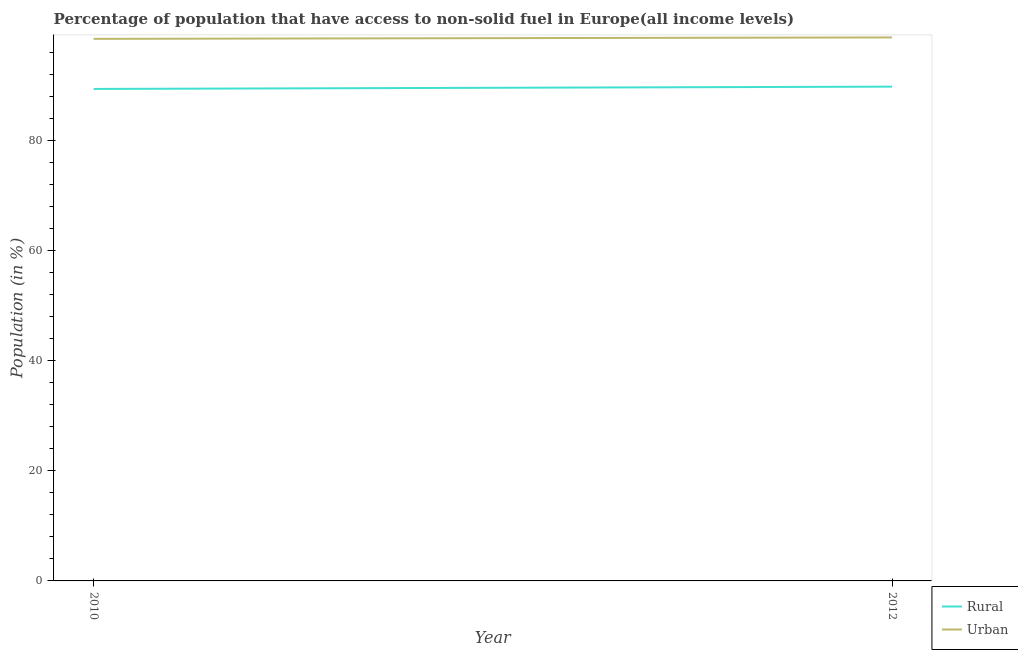Does the line corresponding to urban population intersect with the line corresponding to rural population?
Make the answer very short. No. Is the number of lines equal to the number of legend labels?
Your answer should be compact. Yes. What is the rural population in 2012?
Your answer should be very brief. 89.81. Across all years, what is the maximum urban population?
Your answer should be very brief. 98.74. Across all years, what is the minimum rural population?
Offer a very short reply. 89.39. In which year was the urban population maximum?
Offer a very short reply. 2012. In which year was the urban population minimum?
Provide a short and direct response. 2010. What is the total rural population in the graph?
Keep it short and to the point. 179.19. What is the difference between the rural population in 2010 and that in 2012?
Provide a succinct answer. -0.42. What is the difference between the rural population in 2012 and the urban population in 2010?
Make the answer very short. -8.68. What is the average urban population per year?
Give a very brief answer. 98.62. In the year 2010, what is the difference between the urban population and rural population?
Provide a succinct answer. 9.1. What is the ratio of the rural population in 2010 to that in 2012?
Make the answer very short. 1. Is the rural population in 2010 less than that in 2012?
Give a very brief answer. Yes. Is the rural population strictly greater than the urban population over the years?
Provide a short and direct response. No. Does the graph contain any zero values?
Keep it short and to the point. No. Where does the legend appear in the graph?
Provide a succinct answer. Bottom right. How many legend labels are there?
Give a very brief answer. 2. How are the legend labels stacked?
Your response must be concise. Vertical. What is the title of the graph?
Offer a terse response. Percentage of population that have access to non-solid fuel in Europe(all income levels). Does "Male" appear as one of the legend labels in the graph?
Offer a terse response. No. What is the label or title of the Y-axis?
Offer a very short reply. Population (in %). What is the Population (in %) of Rural in 2010?
Make the answer very short. 89.39. What is the Population (in %) of Urban in 2010?
Provide a succinct answer. 98.49. What is the Population (in %) in Rural in 2012?
Your response must be concise. 89.81. What is the Population (in %) of Urban in 2012?
Your answer should be compact. 98.74. Across all years, what is the maximum Population (in %) of Rural?
Keep it short and to the point. 89.81. Across all years, what is the maximum Population (in %) of Urban?
Ensure brevity in your answer.  98.74. Across all years, what is the minimum Population (in %) in Rural?
Provide a succinct answer. 89.39. Across all years, what is the minimum Population (in %) in Urban?
Provide a short and direct response. 98.49. What is the total Population (in %) in Rural in the graph?
Offer a terse response. 179.19. What is the total Population (in %) in Urban in the graph?
Your answer should be very brief. 197.23. What is the difference between the Population (in %) in Rural in 2010 and that in 2012?
Your answer should be very brief. -0.42. What is the difference between the Population (in %) in Urban in 2010 and that in 2012?
Provide a short and direct response. -0.26. What is the difference between the Population (in %) of Rural in 2010 and the Population (in %) of Urban in 2012?
Keep it short and to the point. -9.36. What is the average Population (in %) of Rural per year?
Offer a very short reply. 89.6. What is the average Population (in %) in Urban per year?
Your answer should be very brief. 98.62. In the year 2010, what is the difference between the Population (in %) in Rural and Population (in %) in Urban?
Keep it short and to the point. -9.1. In the year 2012, what is the difference between the Population (in %) in Rural and Population (in %) in Urban?
Make the answer very short. -8.94. What is the ratio of the Population (in %) of Urban in 2010 to that in 2012?
Give a very brief answer. 1. What is the difference between the highest and the second highest Population (in %) in Rural?
Provide a succinct answer. 0.42. What is the difference between the highest and the second highest Population (in %) of Urban?
Make the answer very short. 0.26. What is the difference between the highest and the lowest Population (in %) in Rural?
Make the answer very short. 0.42. What is the difference between the highest and the lowest Population (in %) in Urban?
Provide a short and direct response. 0.26. 